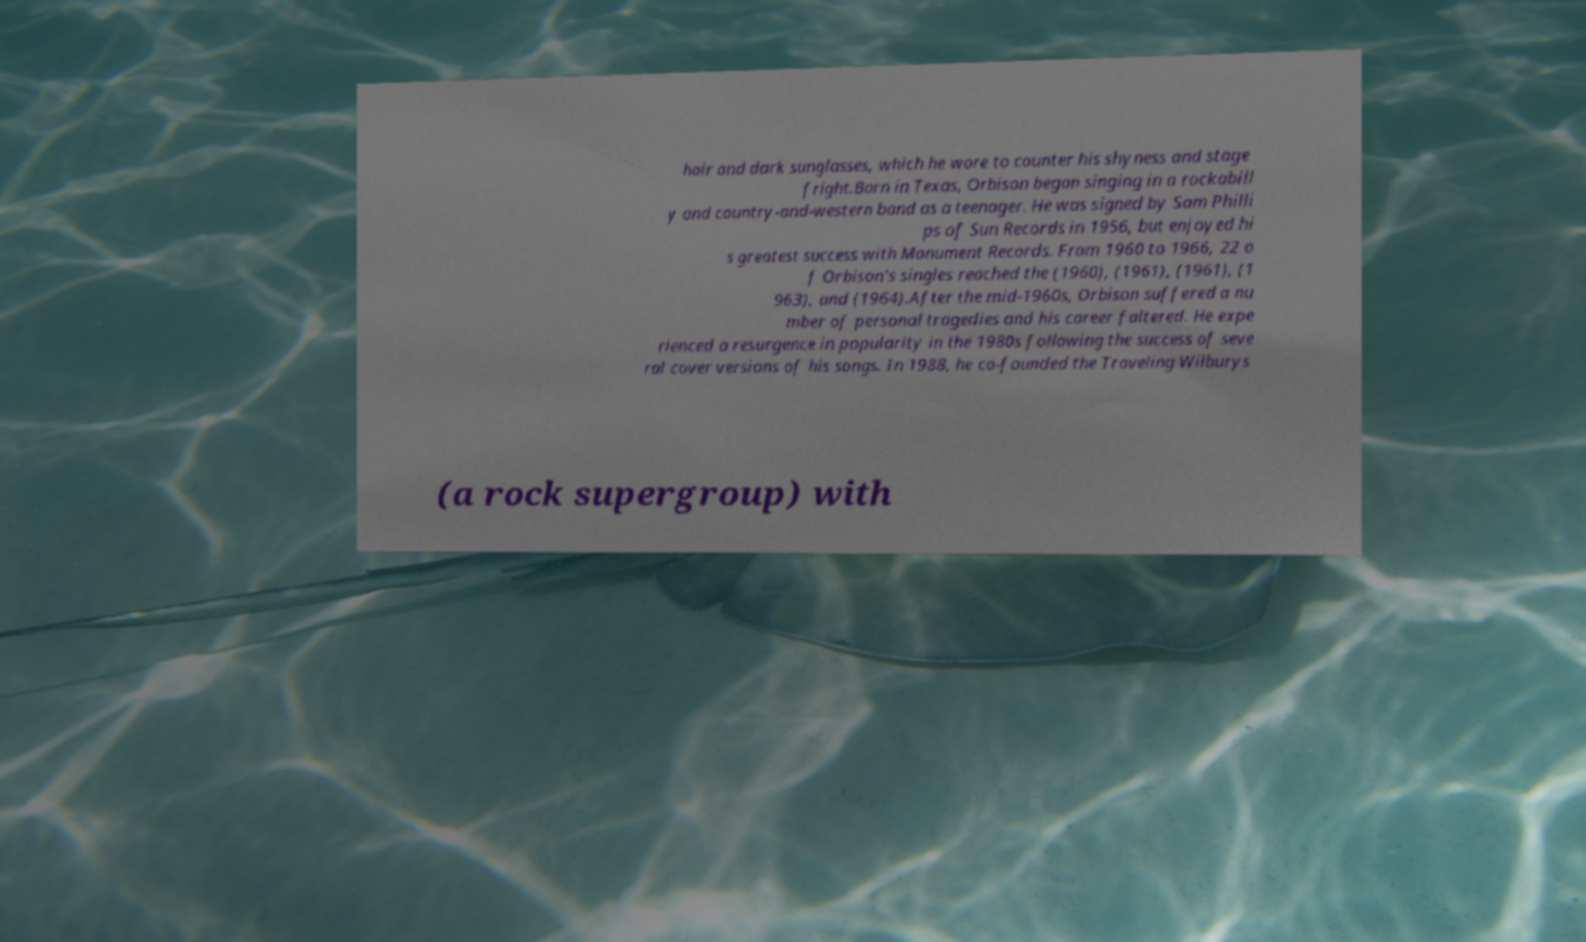Please read and relay the text visible in this image. What does it say? hair and dark sunglasses, which he wore to counter his shyness and stage fright.Born in Texas, Orbison began singing in a rockabill y and country-and-western band as a teenager. He was signed by Sam Philli ps of Sun Records in 1956, but enjoyed hi s greatest success with Monument Records. From 1960 to 1966, 22 o f Orbison's singles reached the (1960), (1961), (1961), (1 963), and (1964).After the mid-1960s, Orbison suffered a nu mber of personal tragedies and his career faltered. He expe rienced a resurgence in popularity in the 1980s following the success of seve ral cover versions of his songs. In 1988, he co-founded the Traveling Wilburys (a rock supergroup) with 